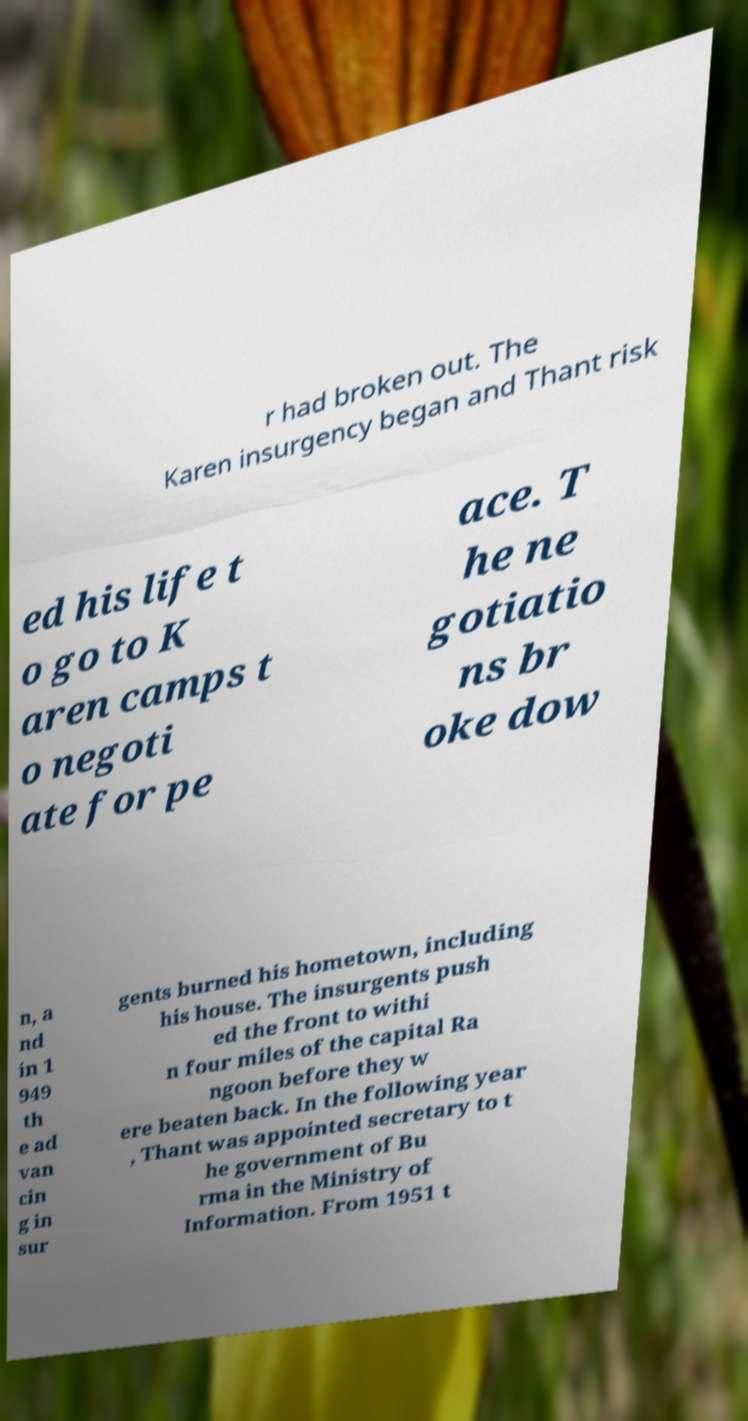Please identify and transcribe the text found in this image. r had broken out. The Karen insurgency began and Thant risk ed his life t o go to K aren camps t o negoti ate for pe ace. T he ne gotiatio ns br oke dow n, a nd in 1 949 th e ad van cin g in sur gents burned his hometown, including his house. The insurgents push ed the front to withi n four miles of the capital Ra ngoon before they w ere beaten back. In the following year , Thant was appointed secretary to t he government of Bu rma in the Ministry of Information. From 1951 t 